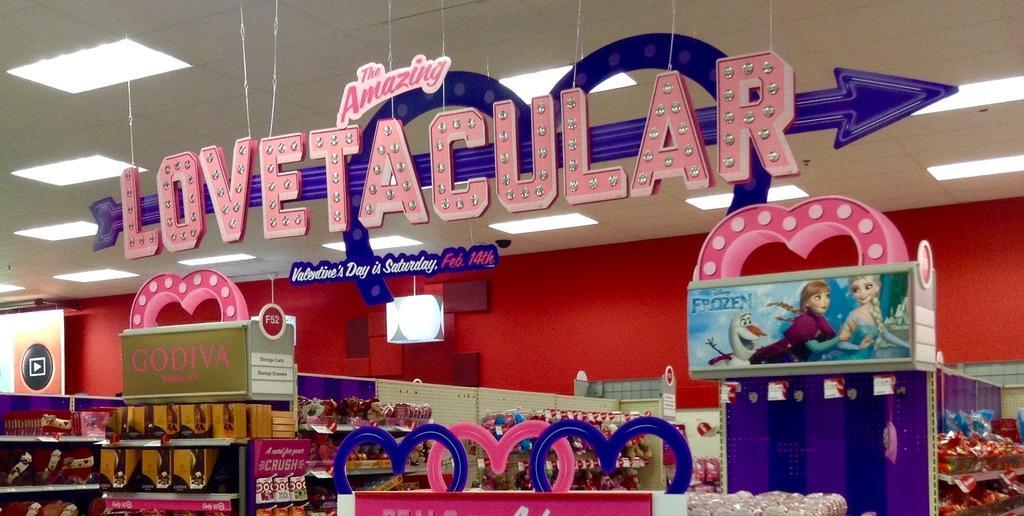Please provide a concise description of this image. In this image it looks like it is a gift shop. At the top there is hoarding which is hanged to the ceiling. On the left side there are chocolate boxes which are kept in the racks. On the right side there are so many gifts which are packed and kept in the racks. 